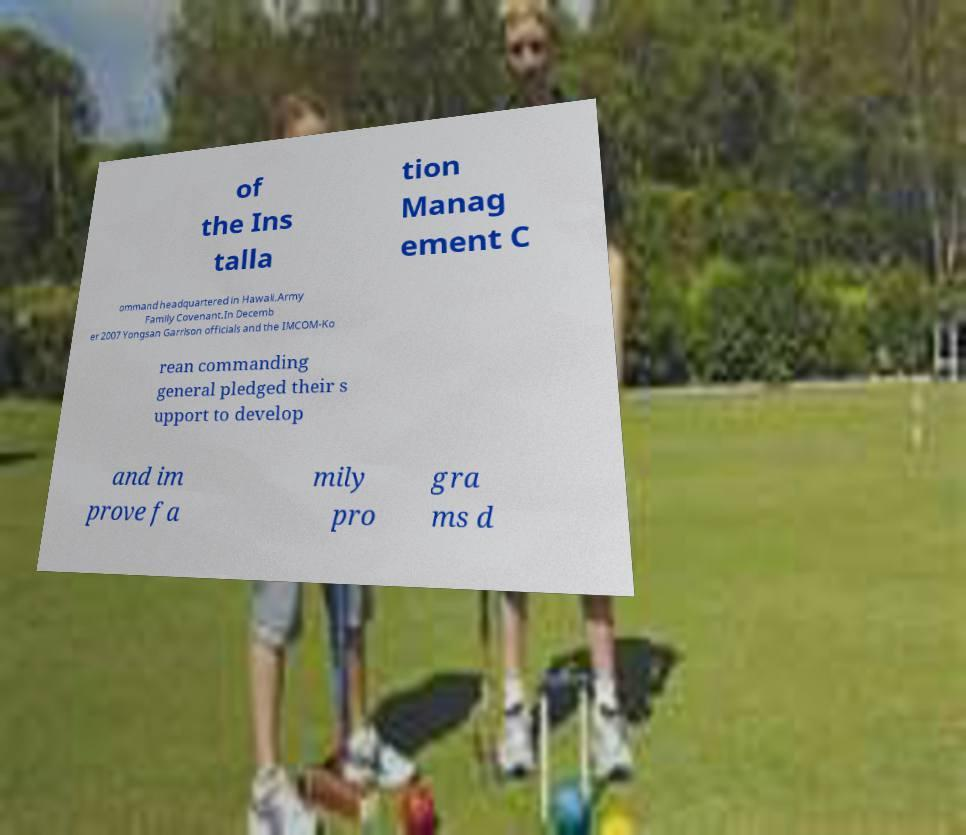Can you accurately transcribe the text from the provided image for me? of the Ins talla tion Manag ement C ommand headquartered in Hawaii.Army Family Covenant.In Decemb er 2007 Yongsan Garrison officials and the IMCOM-Ko rean commanding general pledged their s upport to develop and im prove fa mily pro gra ms d 